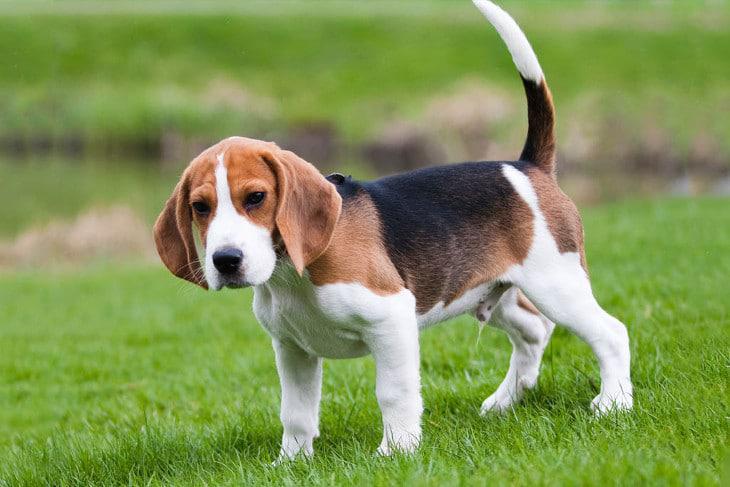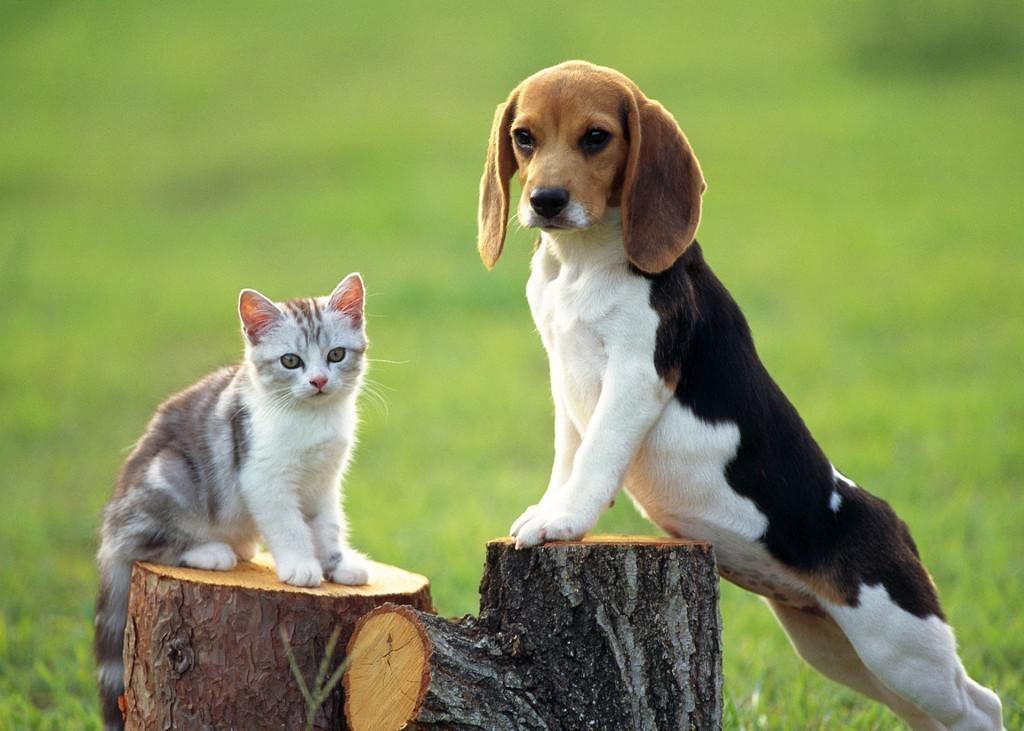The first image is the image on the left, the second image is the image on the right. Considering the images on both sides, is "At least one dog has its mouth open." valid? Answer yes or no. No. 